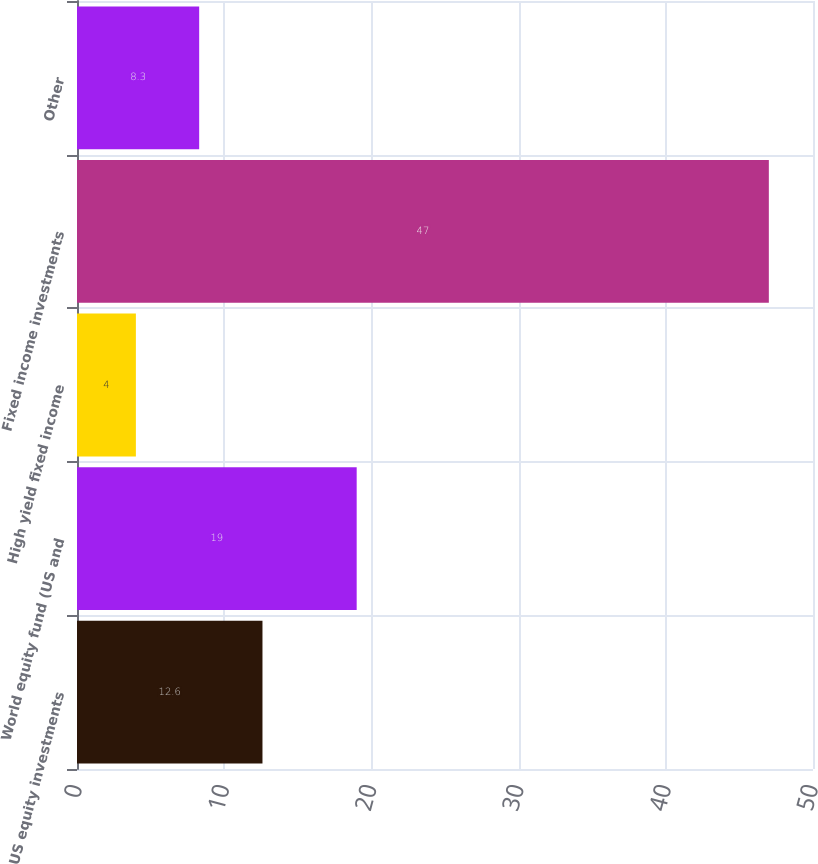<chart> <loc_0><loc_0><loc_500><loc_500><bar_chart><fcel>US equity investments<fcel>World equity fund (US and<fcel>High yield fixed income<fcel>Fixed income investments<fcel>Other<nl><fcel>12.6<fcel>19<fcel>4<fcel>47<fcel>8.3<nl></chart> 